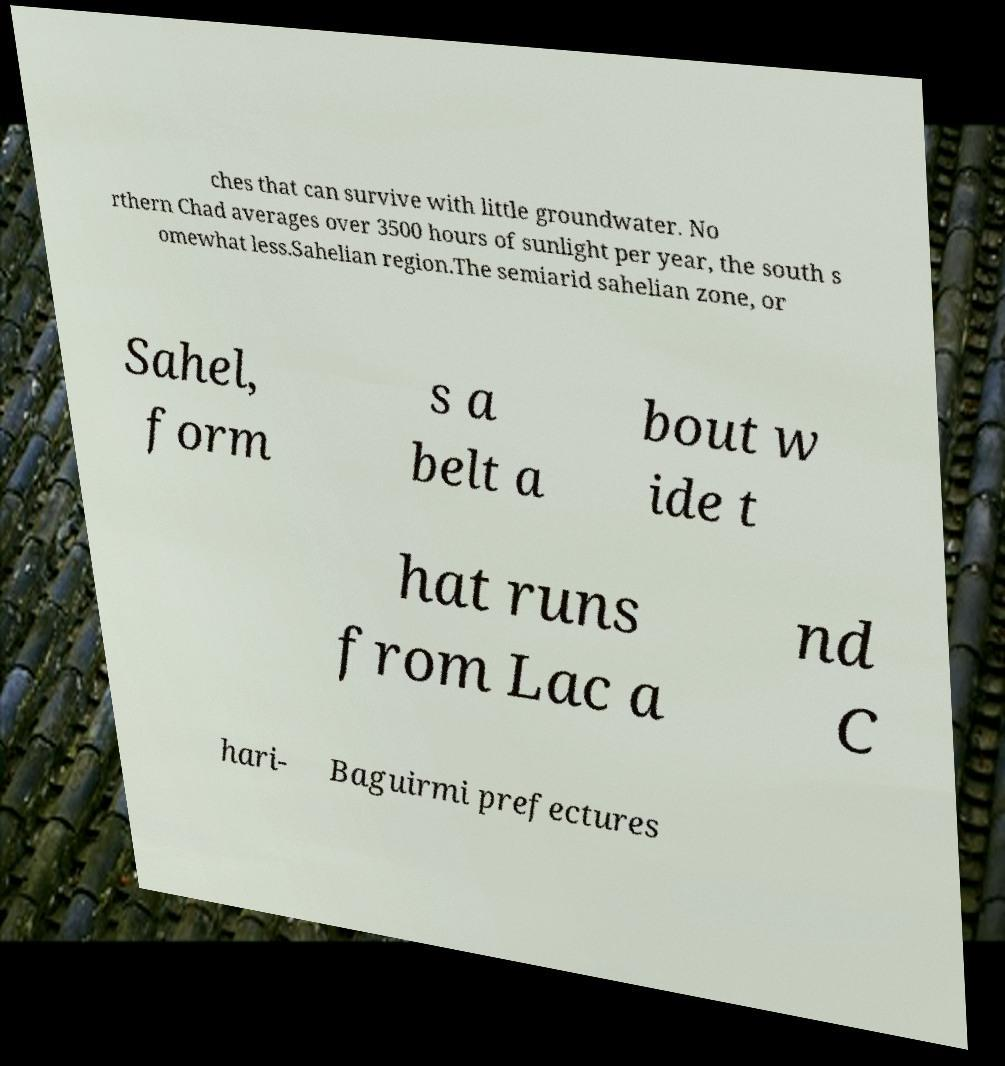Could you extract and type out the text from this image? ches that can survive with little groundwater. No rthern Chad averages over 3500 hours of sunlight per year, the south s omewhat less.Sahelian region.The semiarid sahelian zone, or Sahel, form s a belt a bout w ide t hat runs from Lac a nd C hari- Baguirmi prefectures 